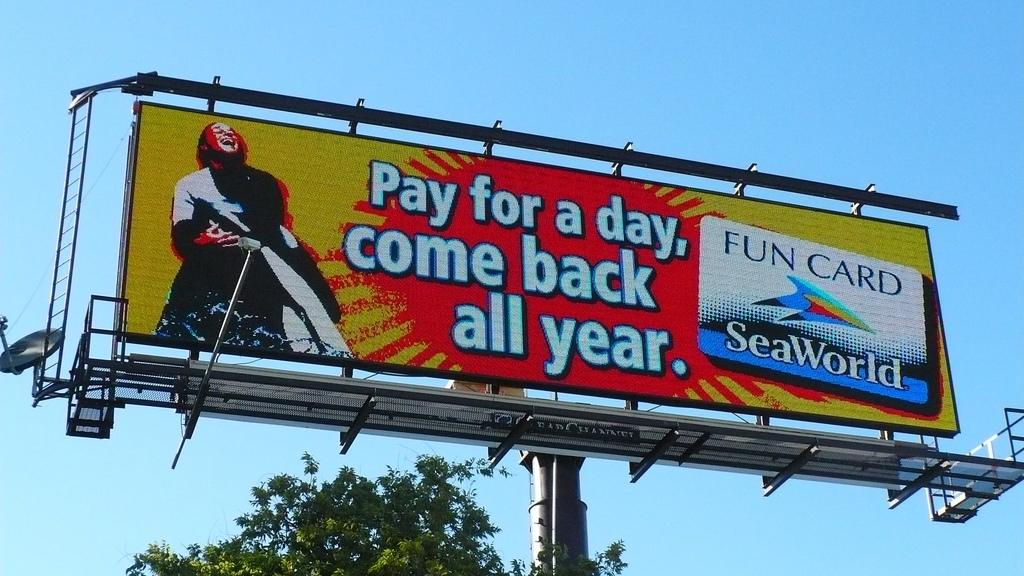<image>
Give a short and clear explanation of the subsequent image. A billboard for SeaWorld's fun card full year pass. 